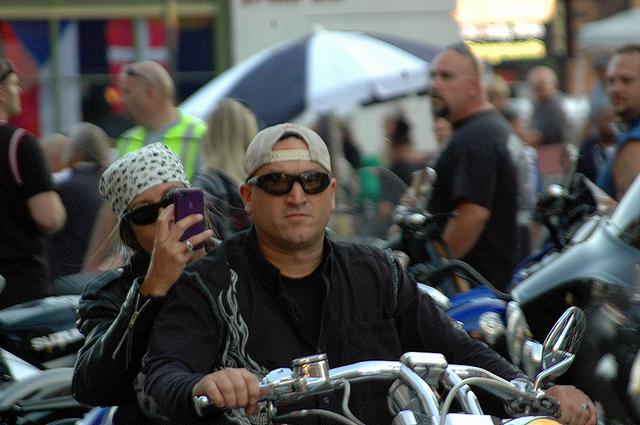Why is the woman wearing a white bandana holding a phone up? Please explain your reasoning. taking pictures. The man is looking at her phone as if aiming the camera at something. 